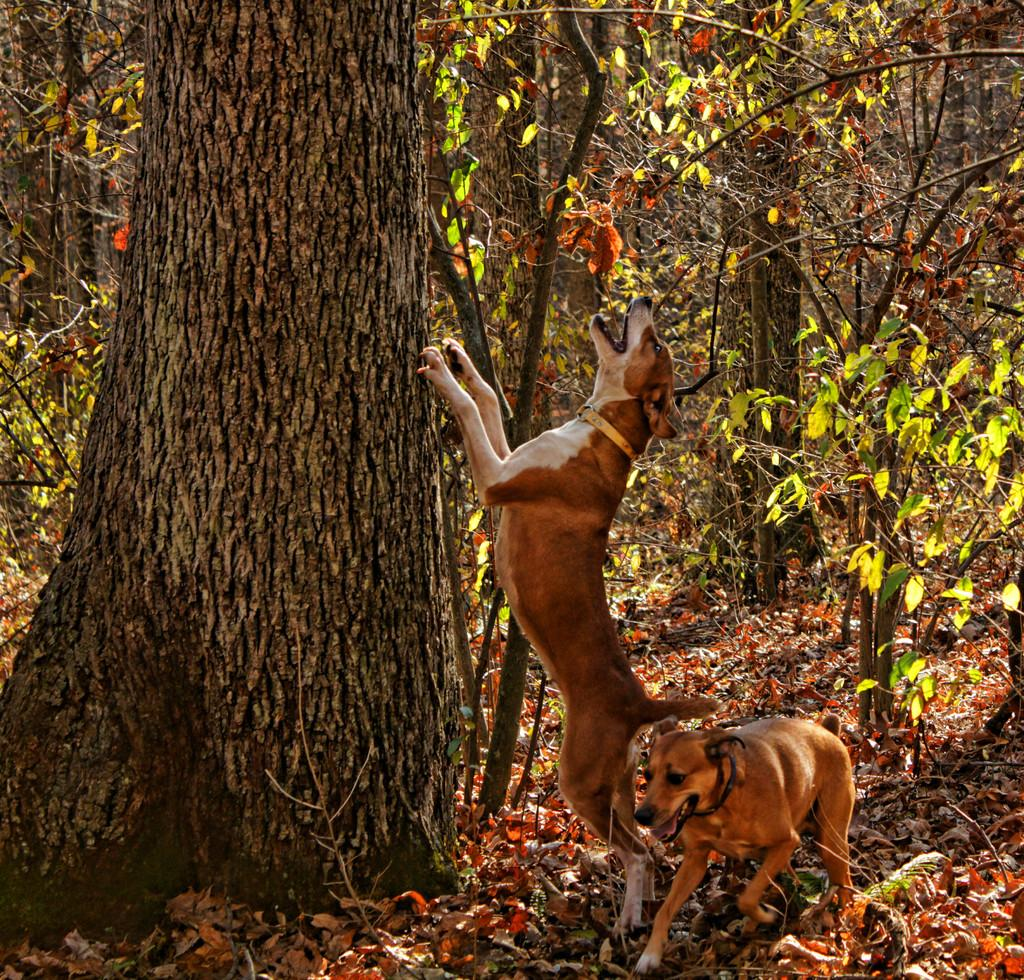How many dogs are in the image? There are two dogs in the image. What is present at the bottom of the image? Dried leaves are present at the bottom of the image. What can be seen in the background of the image? There are trees in the background of the image. What type of coil is being used by the dogs in the image? There is no coil present in the image; the dogs are not using any tools or objects. 